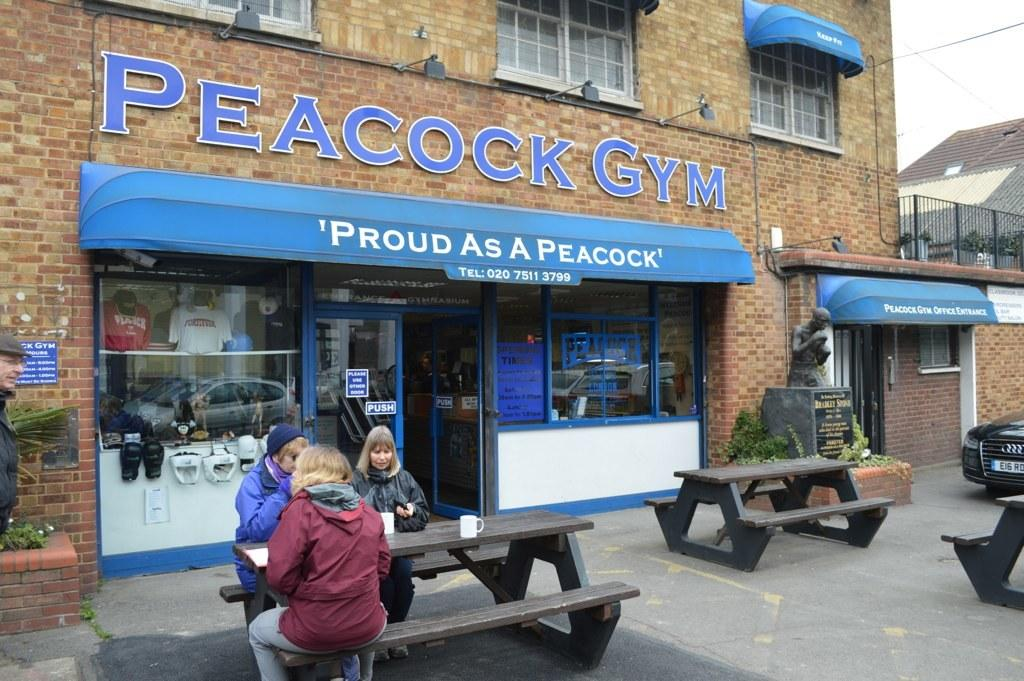What type of structure is visible in the image? There is a building in the image. What are the people in the image doing? There are three people seated on a bench in the image. What objects are on the bench with the people? There are cups on the bench. What mode of transportation is parked in the image? There is a car parked in the image. What additional feature can be seen in the image? There is a statue in the image. Can you describe the position of the man in the image? There is a man standing in the image. What type of yarn is the statue using to knit in the image? There is no yarn or knitting depicted in the image; the statue is not engaged in any such activity. What direction is the band walking in the image? There is no band present in the image, so it is not possible to determine their direction of movement. 